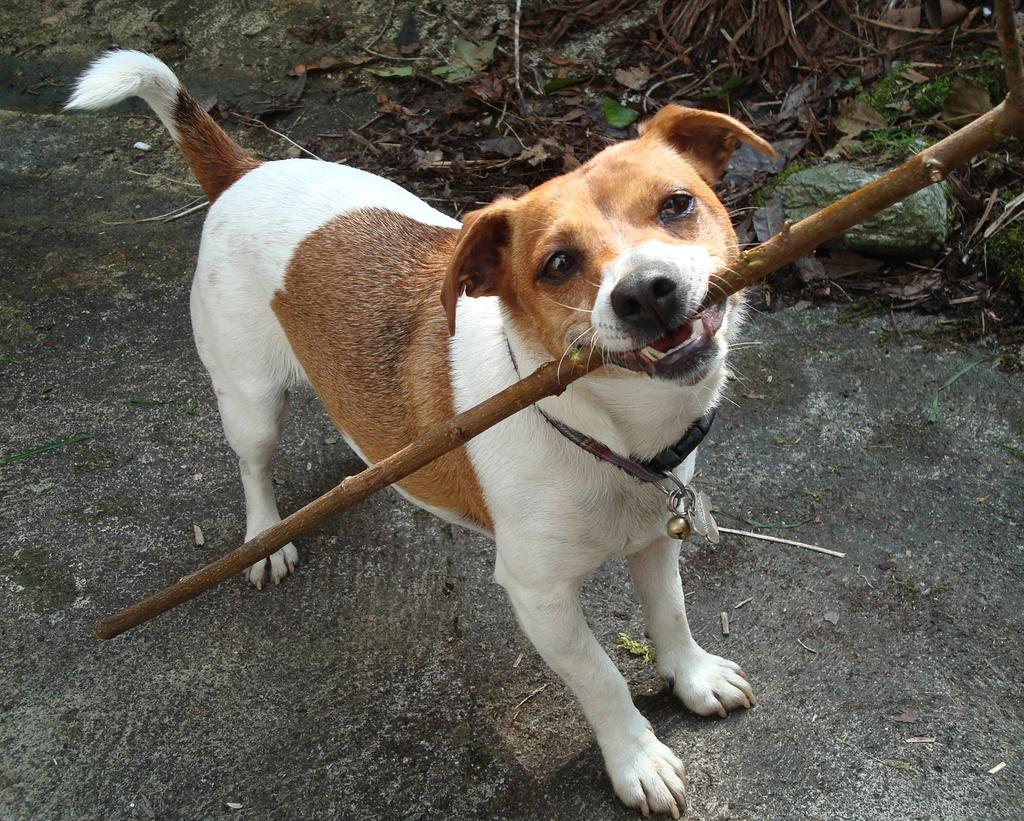What animal can be seen in the picture? There is a dog in the picture. What is the dog holding in its mouth? The dog is holding a wooden stick in its mouth. Is there any accessory around the dog's neck? Yes, there is a belt around the dog's neck. What is attached to the belt? A small ball is attached to the belt. What type of ship can be seen in the background of the image? There is no ship present in the image; it features a dog holding a wooden stick and wearing a belt with a small ball attached. What kind of lunch is the laborer eating in the image? There is no laborer or lunch present in the image; it features a dog holding a wooden stick and wearing a belt with a small ball attached. 